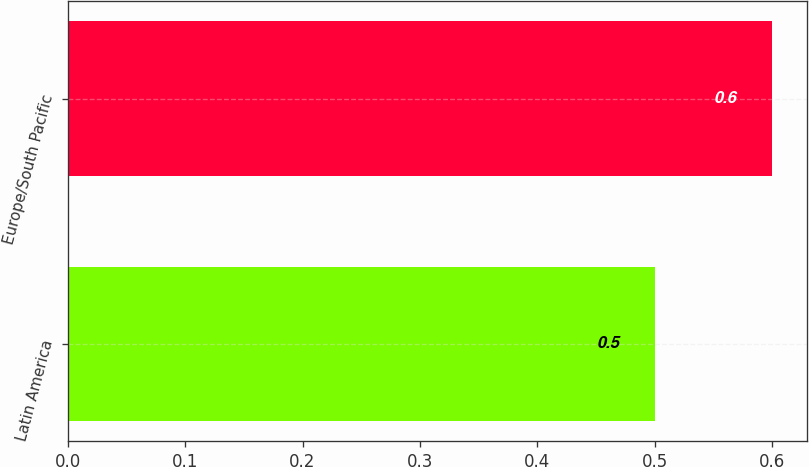Convert chart to OTSL. <chart><loc_0><loc_0><loc_500><loc_500><bar_chart><fcel>Latin America<fcel>Europe/South Pacific<nl><fcel>0.5<fcel>0.6<nl></chart> 